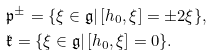<formula> <loc_0><loc_0><loc_500><loc_500>& \mathfrak { p } ^ { \pm } = \{ \xi \in \mathfrak { g } | \, [ h _ { 0 } , \xi ] = \pm 2 \xi \} , \\ & \mathfrak { k } = \{ \xi \in \mathfrak { g } | \, [ h _ { 0 } , \xi ] = 0 \} .</formula> 